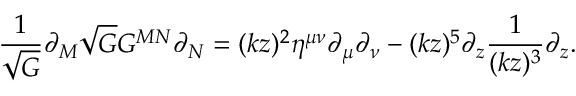Convert formula to latex. <formula><loc_0><loc_0><loc_500><loc_500>\frac { 1 } { \sqrt { G } } \partial _ { M } \sqrt { G } G ^ { M N } \partial _ { N } = ( k z ) ^ { 2 } \eta ^ { \mu \nu } \partial _ { \mu } \partial _ { \nu } - ( k z ) ^ { 5 } \partial _ { z } \frac { 1 } { ( k z ) ^ { 3 } } \partial _ { z } .</formula> 